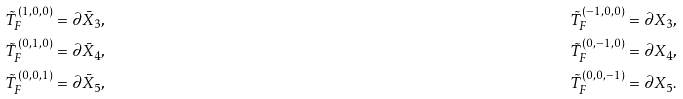Convert formula to latex. <formula><loc_0><loc_0><loc_500><loc_500>& \tilde { T } _ { F } ^ { ( 1 , 0 , 0 ) } = \partial \bar { X } _ { 3 } , & & \tilde { T } _ { F } ^ { ( - 1 , 0 , 0 ) } = \partial X _ { 3 } , \\ & \tilde { T } _ { F } ^ { ( 0 , 1 , 0 ) } = \partial \bar { X } _ { 4 } , & & \tilde { T } _ { F } ^ { ( 0 , - 1 , 0 ) } = \partial X _ { 4 } , \\ & \tilde { T } _ { F } ^ { ( 0 , 0 , 1 ) } = \partial \bar { X } _ { 5 } , & & \tilde { T } _ { F } ^ { ( 0 , 0 , - 1 ) } = \partial X _ { 5 } .</formula> 